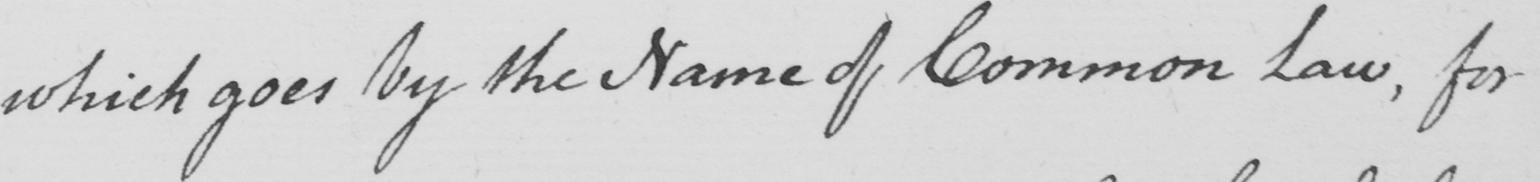Please provide the text content of this handwritten line. which goes by the Name of Common Law , for 